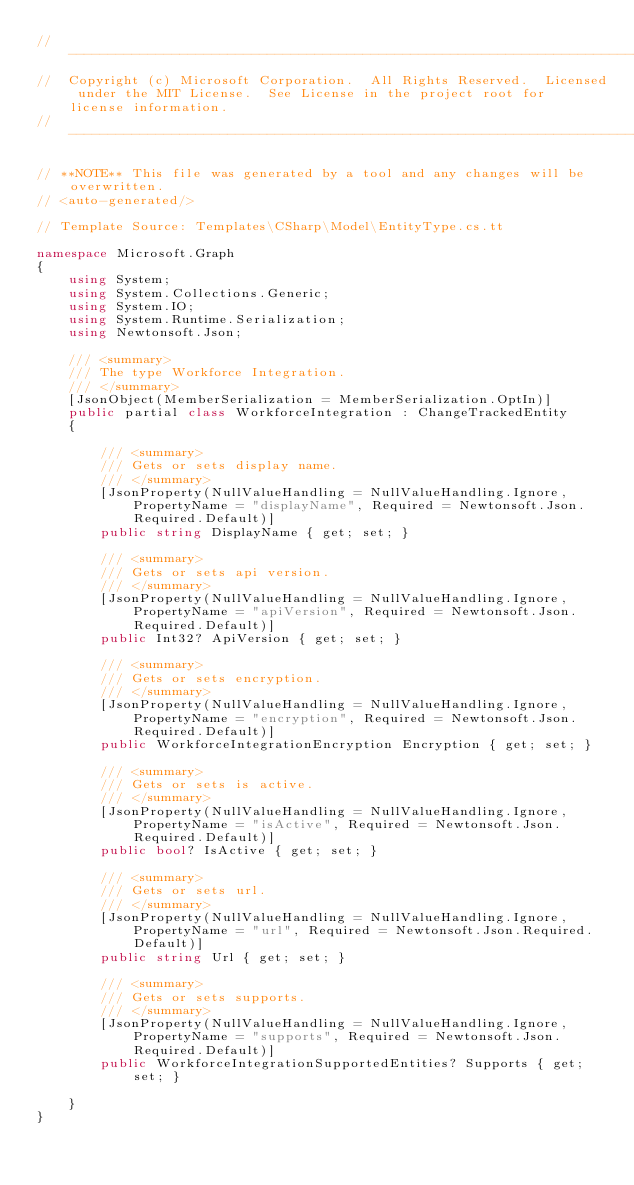<code> <loc_0><loc_0><loc_500><loc_500><_C#_>// ------------------------------------------------------------------------------
//  Copyright (c) Microsoft Corporation.  All Rights Reserved.  Licensed under the MIT License.  See License in the project root for license information.
// ------------------------------------------------------------------------------

// **NOTE** This file was generated by a tool and any changes will be overwritten.
// <auto-generated/>

// Template Source: Templates\CSharp\Model\EntityType.cs.tt

namespace Microsoft.Graph
{
    using System;
    using System.Collections.Generic;
    using System.IO;
    using System.Runtime.Serialization;
    using Newtonsoft.Json;

    /// <summary>
    /// The type Workforce Integration.
    /// </summary>
    [JsonObject(MemberSerialization = MemberSerialization.OptIn)]
    public partial class WorkforceIntegration : ChangeTrackedEntity
    {
    
        /// <summary>
        /// Gets or sets display name.
        /// </summary>
        [JsonProperty(NullValueHandling = NullValueHandling.Ignore, PropertyName = "displayName", Required = Newtonsoft.Json.Required.Default)]
        public string DisplayName { get; set; }
    
        /// <summary>
        /// Gets or sets api version.
        /// </summary>
        [JsonProperty(NullValueHandling = NullValueHandling.Ignore, PropertyName = "apiVersion", Required = Newtonsoft.Json.Required.Default)]
        public Int32? ApiVersion { get; set; }
    
        /// <summary>
        /// Gets or sets encryption.
        /// </summary>
        [JsonProperty(NullValueHandling = NullValueHandling.Ignore, PropertyName = "encryption", Required = Newtonsoft.Json.Required.Default)]
        public WorkforceIntegrationEncryption Encryption { get; set; }
    
        /// <summary>
        /// Gets or sets is active.
        /// </summary>
        [JsonProperty(NullValueHandling = NullValueHandling.Ignore, PropertyName = "isActive", Required = Newtonsoft.Json.Required.Default)]
        public bool? IsActive { get; set; }
    
        /// <summary>
        /// Gets or sets url.
        /// </summary>
        [JsonProperty(NullValueHandling = NullValueHandling.Ignore, PropertyName = "url", Required = Newtonsoft.Json.Required.Default)]
        public string Url { get; set; }
    
        /// <summary>
        /// Gets or sets supports.
        /// </summary>
        [JsonProperty(NullValueHandling = NullValueHandling.Ignore, PropertyName = "supports", Required = Newtonsoft.Json.Required.Default)]
        public WorkforceIntegrationSupportedEntities? Supports { get; set; }
    
    }
}

</code> 